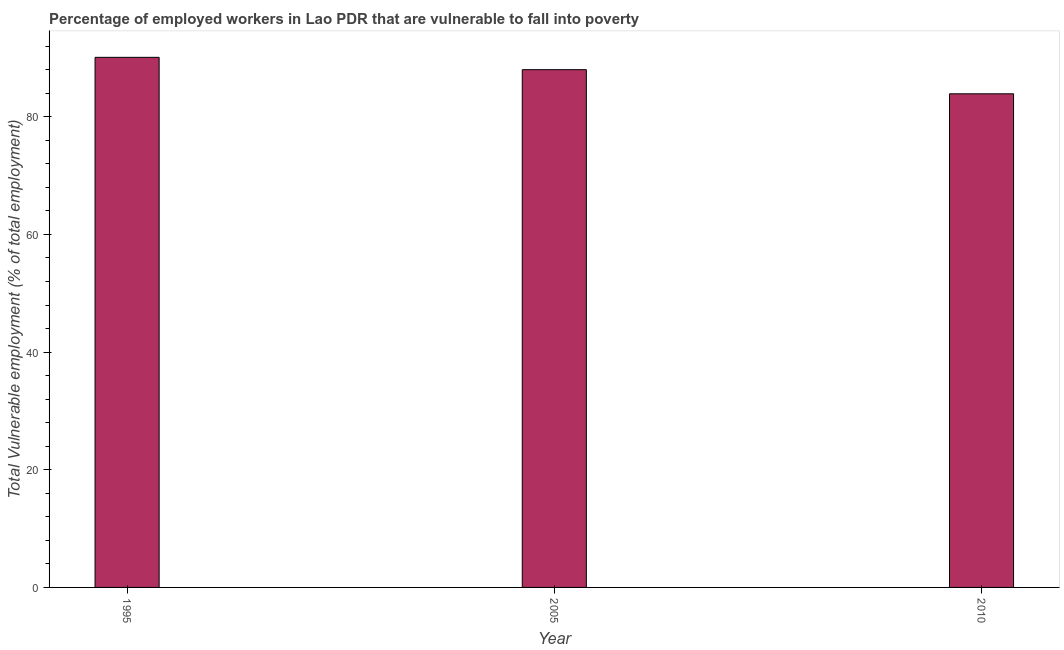Does the graph contain any zero values?
Give a very brief answer. No. What is the title of the graph?
Keep it short and to the point. Percentage of employed workers in Lao PDR that are vulnerable to fall into poverty. What is the label or title of the X-axis?
Make the answer very short. Year. What is the label or title of the Y-axis?
Make the answer very short. Total Vulnerable employment (% of total employment). What is the total vulnerable employment in 2010?
Give a very brief answer. 83.9. Across all years, what is the maximum total vulnerable employment?
Keep it short and to the point. 90.1. Across all years, what is the minimum total vulnerable employment?
Make the answer very short. 83.9. What is the sum of the total vulnerable employment?
Your response must be concise. 262. What is the average total vulnerable employment per year?
Offer a very short reply. 87.33. In how many years, is the total vulnerable employment greater than 12 %?
Your answer should be compact. 3. What is the ratio of the total vulnerable employment in 2005 to that in 2010?
Your answer should be very brief. 1.05. Is the total vulnerable employment in 1995 less than that in 2010?
Your answer should be compact. No. What is the difference between the highest and the second highest total vulnerable employment?
Provide a succinct answer. 2.1. What is the difference between the highest and the lowest total vulnerable employment?
Give a very brief answer. 6.2. In how many years, is the total vulnerable employment greater than the average total vulnerable employment taken over all years?
Offer a terse response. 2. How many bars are there?
Keep it short and to the point. 3. Are all the bars in the graph horizontal?
Offer a terse response. No. How many years are there in the graph?
Offer a terse response. 3. Are the values on the major ticks of Y-axis written in scientific E-notation?
Your answer should be compact. No. What is the Total Vulnerable employment (% of total employment) in 1995?
Provide a short and direct response. 90.1. What is the Total Vulnerable employment (% of total employment) of 2010?
Your answer should be compact. 83.9. What is the difference between the Total Vulnerable employment (% of total employment) in 1995 and 2005?
Your answer should be very brief. 2.1. What is the difference between the Total Vulnerable employment (% of total employment) in 2005 and 2010?
Your answer should be very brief. 4.1. What is the ratio of the Total Vulnerable employment (% of total employment) in 1995 to that in 2005?
Offer a terse response. 1.02. What is the ratio of the Total Vulnerable employment (% of total employment) in 1995 to that in 2010?
Give a very brief answer. 1.07. What is the ratio of the Total Vulnerable employment (% of total employment) in 2005 to that in 2010?
Your answer should be very brief. 1.05. 